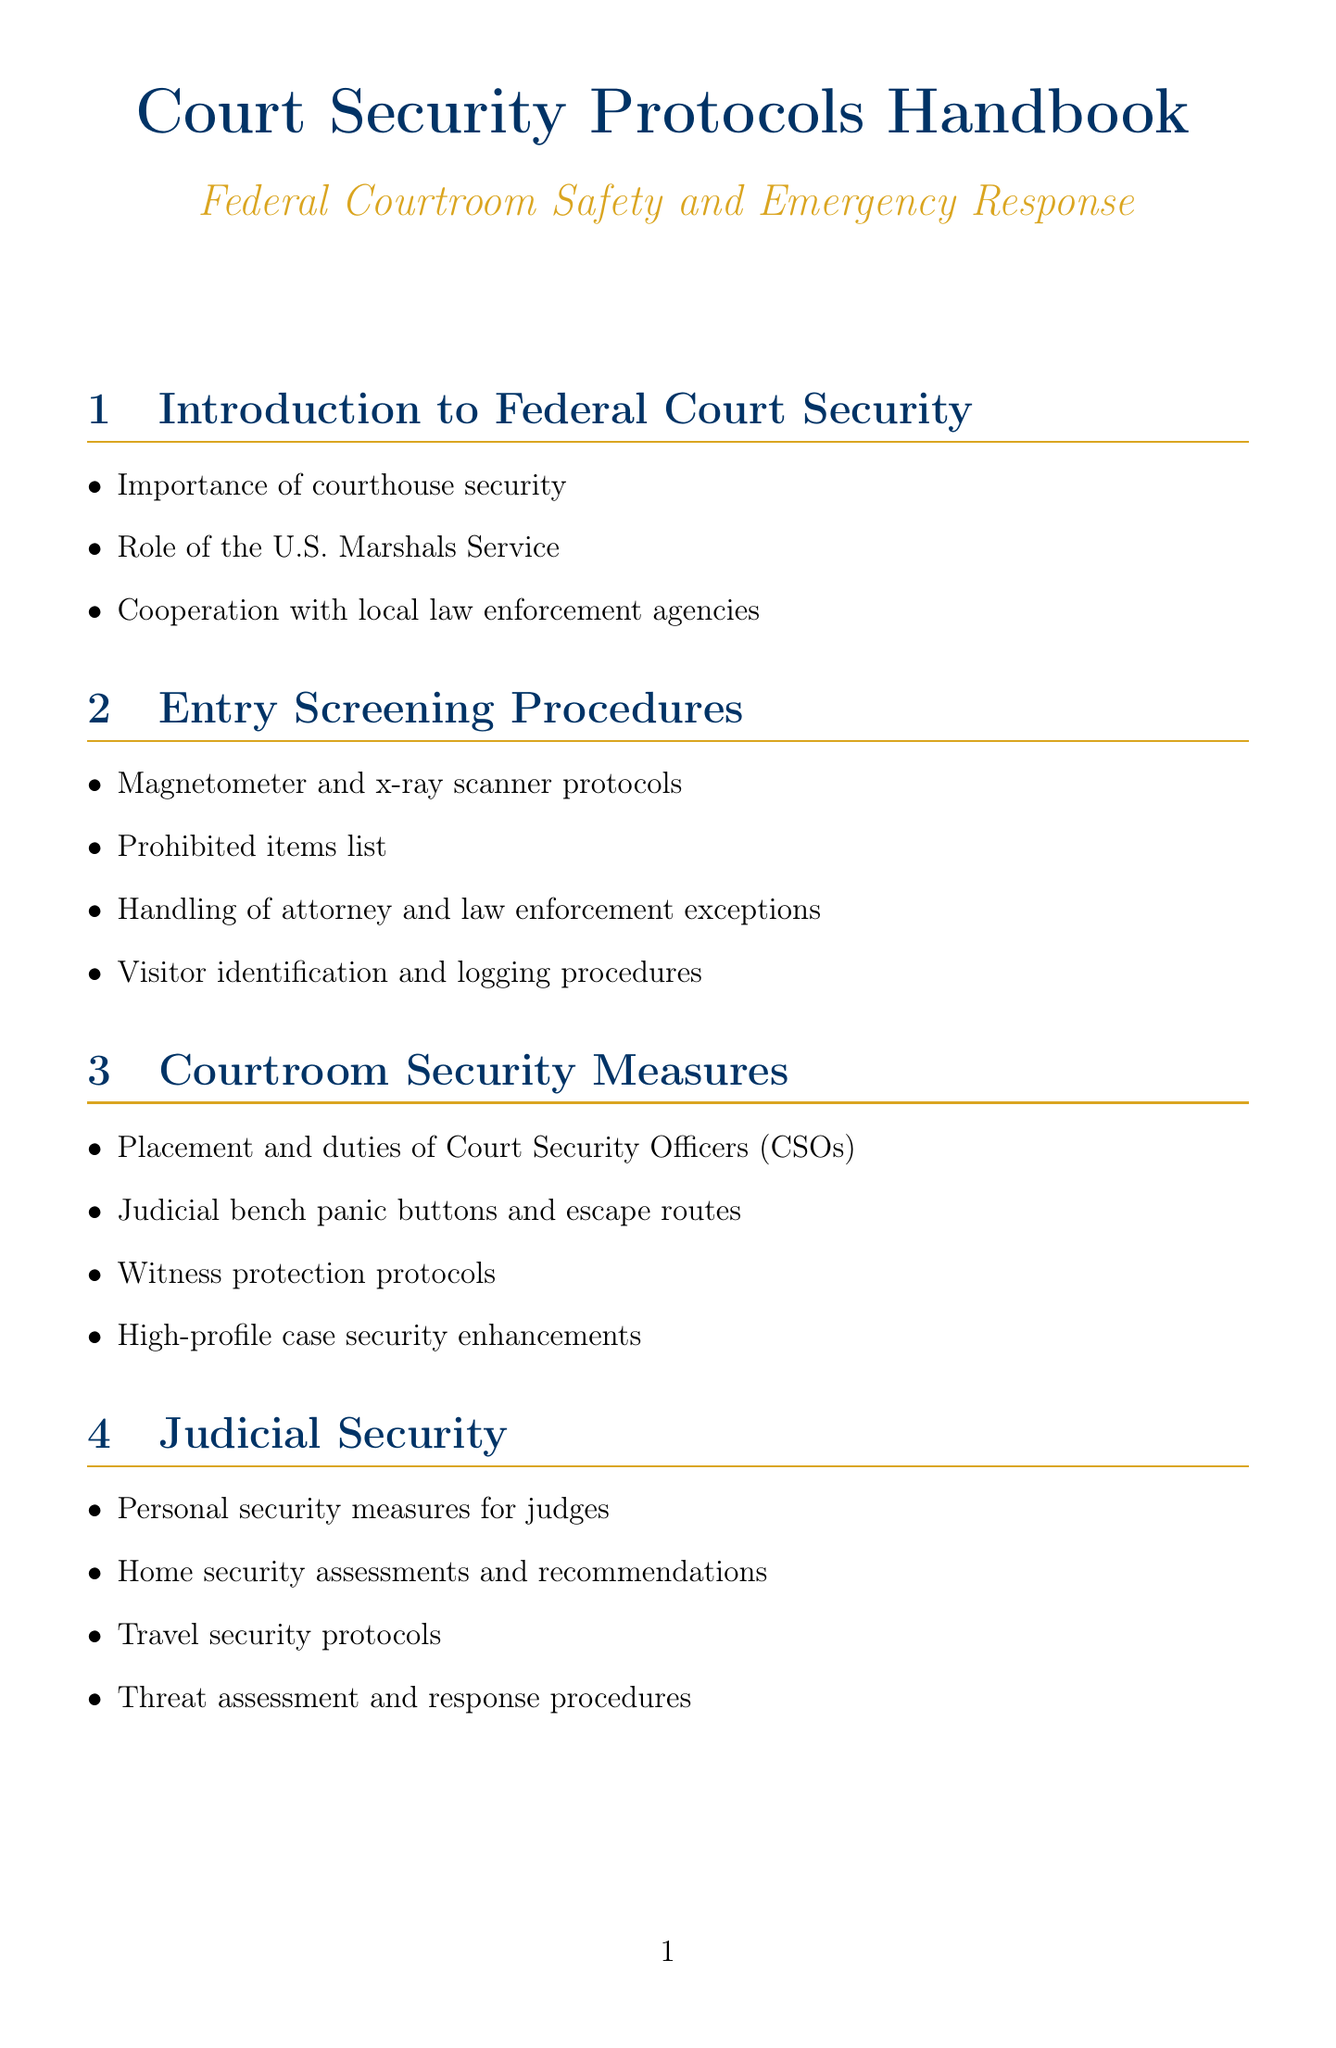What is the title of the handbook? The title of the handbook is mentioned at the beginning of the document.
Answer: Court Security Protocols Handbook Who is the Chief Judge? The Chief Judge's name and role are listed in the Key Personnel section of the document.
Answer: Hon. Merrick B. Garland What is the hotline for the Federal Protective Service? The hotline number is specified in the Emergency Contacts section.
Answer: 1-877-4FPS-411 What security system is used for video surveillance and access control? The document lists specific security systems in the Security Systems section, detailing their purposes.
Answer: Genetec Security Center What is the completion date of the ballistic glass installation project? The completion date is provided alongside the project's description in the Recent Security Enhancements section.
Answer: 2023-03-15 What special consideration is made for semi-retired judges? The document outlines specific accommodations in the Special Considerations for Senior Judges section.
Answer: Modified security protocols How often are emergency response drills conducted? The frequency of drills is mentioned in the Training and Drills section of the handbook.
Answer: Quarterly Which agency is responsible for threat intelligence coordination? The document mentions the agency involved in this coordination within the Interagency Cooperation section.
Answer: FBI What type of response plan is included for active shooters? The document highlights various emergency response plans, including this specific type.
Answer: Active shooter response 